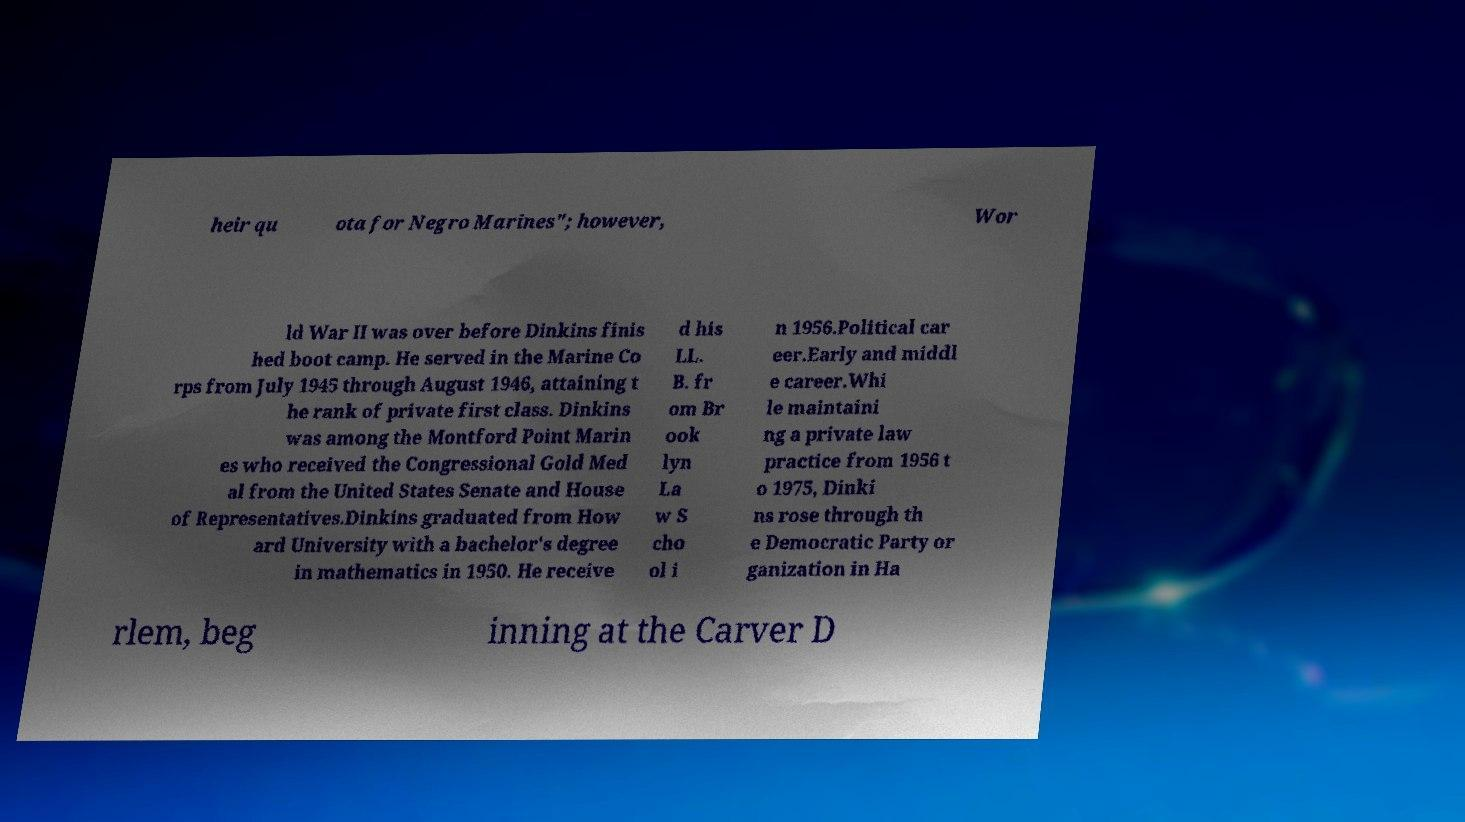Could you extract and type out the text from this image? heir qu ota for Negro Marines"; however, Wor ld War II was over before Dinkins finis hed boot camp. He served in the Marine Co rps from July 1945 through August 1946, attaining t he rank of private first class. Dinkins was among the Montford Point Marin es who received the Congressional Gold Med al from the United States Senate and House of Representatives.Dinkins graduated from How ard University with a bachelor's degree in mathematics in 1950. He receive d his LL. B. fr om Br ook lyn La w S cho ol i n 1956.Political car eer.Early and middl e career.Whi le maintaini ng a private law practice from 1956 t o 1975, Dinki ns rose through th e Democratic Party or ganization in Ha rlem, beg inning at the Carver D 